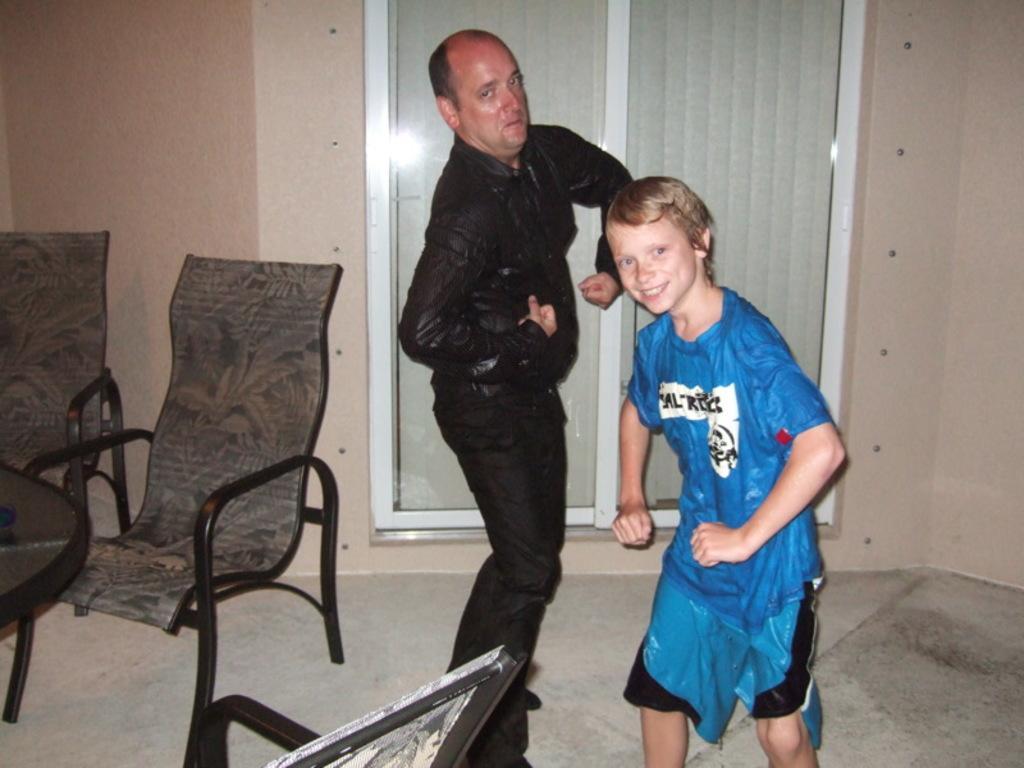How would you summarize this image in a sentence or two? Here we can a see man and a boy. They are wearing a wet clothes. Here we can see a table and chairs on the left side. 